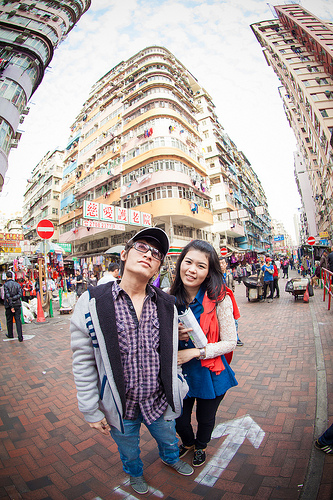<image>
Can you confirm if the girl is behind the boy? Yes. From this viewpoint, the girl is positioned behind the boy, with the boy partially or fully occluding the girl. Is the paper in front of the jacket? No. The paper is not in front of the jacket. The spatial positioning shows a different relationship between these objects. 